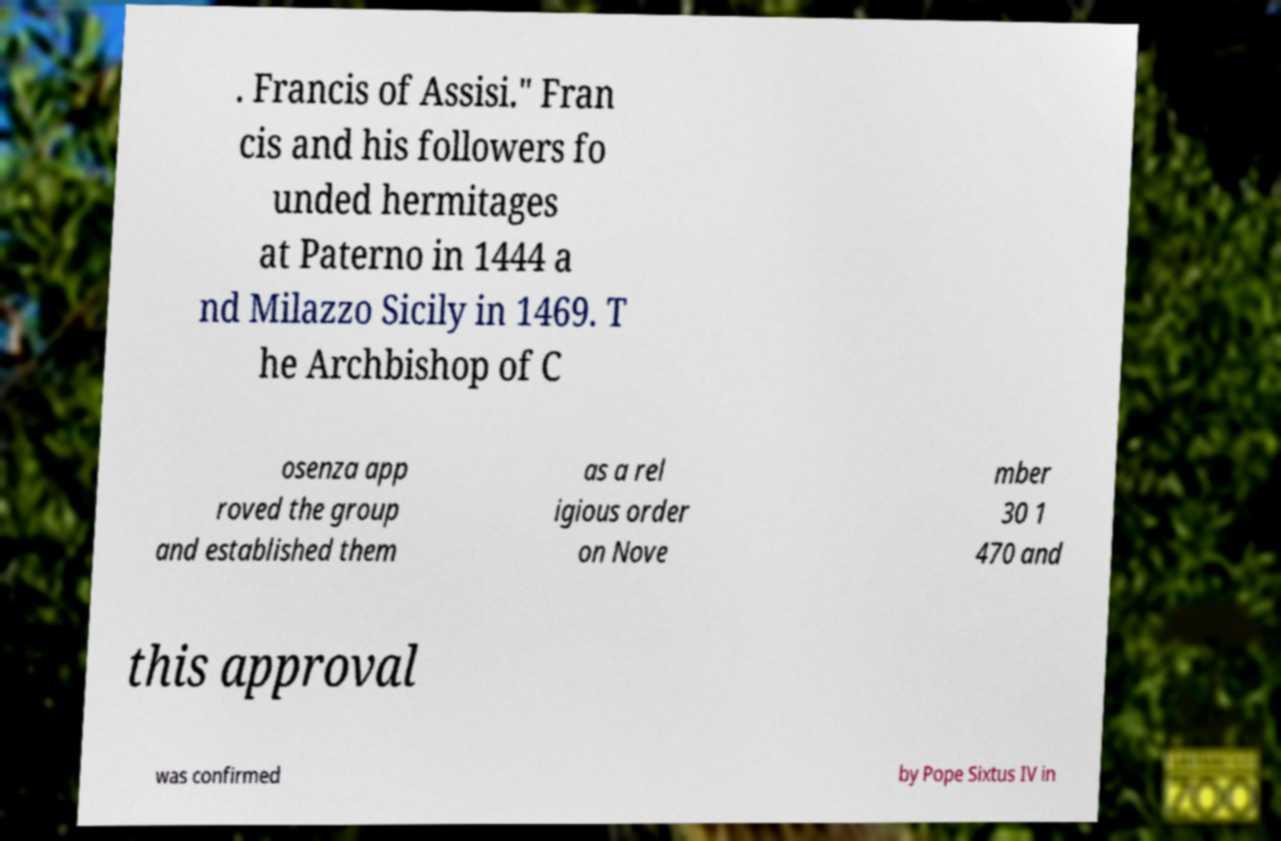There's text embedded in this image that I need extracted. Can you transcribe it verbatim? . Francis of Assisi." Fran cis and his followers fo unded hermitages at Paterno in 1444 a nd Milazzo Sicily in 1469. T he Archbishop of C osenza app roved the group and established them as a rel igious order on Nove mber 30 1 470 and this approval was confirmed by Pope Sixtus IV in 